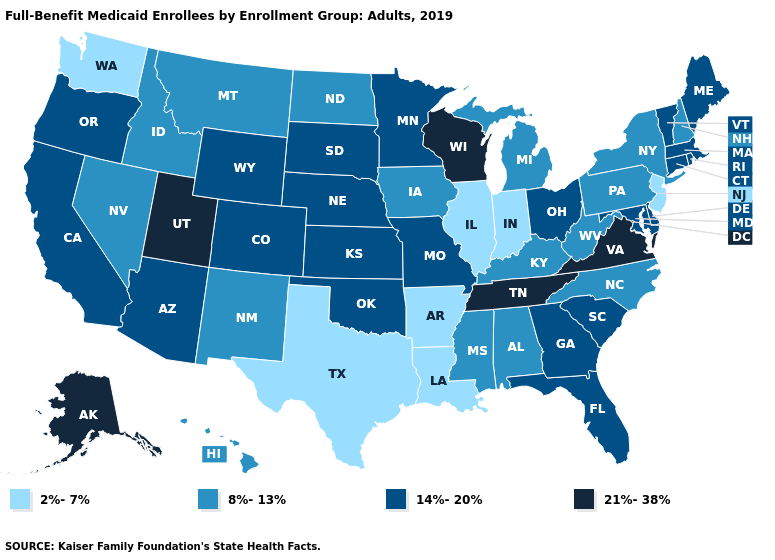Which states have the highest value in the USA?
Concise answer only. Alaska, Tennessee, Utah, Virginia, Wisconsin. Does Pennsylvania have a higher value than Arkansas?
Concise answer only. Yes. Does Alaska have the highest value in the USA?
Answer briefly. Yes. Name the states that have a value in the range 14%-20%?
Answer briefly. Arizona, California, Colorado, Connecticut, Delaware, Florida, Georgia, Kansas, Maine, Maryland, Massachusetts, Minnesota, Missouri, Nebraska, Ohio, Oklahoma, Oregon, Rhode Island, South Carolina, South Dakota, Vermont, Wyoming. Name the states that have a value in the range 14%-20%?
Be succinct. Arizona, California, Colorado, Connecticut, Delaware, Florida, Georgia, Kansas, Maine, Maryland, Massachusetts, Minnesota, Missouri, Nebraska, Ohio, Oklahoma, Oregon, Rhode Island, South Carolina, South Dakota, Vermont, Wyoming. What is the value of Massachusetts?
Quick response, please. 14%-20%. Does South Dakota have a lower value than Kentucky?
Answer briefly. No. What is the value of North Carolina?
Short answer required. 8%-13%. Name the states that have a value in the range 21%-38%?
Be succinct. Alaska, Tennessee, Utah, Virginia, Wisconsin. Name the states that have a value in the range 14%-20%?
Write a very short answer. Arizona, California, Colorado, Connecticut, Delaware, Florida, Georgia, Kansas, Maine, Maryland, Massachusetts, Minnesota, Missouri, Nebraska, Ohio, Oklahoma, Oregon, Rhode Island, South Carolina, South Dakota, Vermont, Wyoming. Name the states that have a value in the range 21%-38%?
Concise answer only. Alaska, Tennessee, Utah, Virginia, Wisconsin. What is the value of Texas?
Write a very short answer. 2%-7%. Does Alaska have the highest value in the West?
Concise answer only. Yes. What is the highest value in the USA?
Give a very brief answer. 21%-38%. What is the lowest value in the South?
Answer briefly. 2%-7%. 